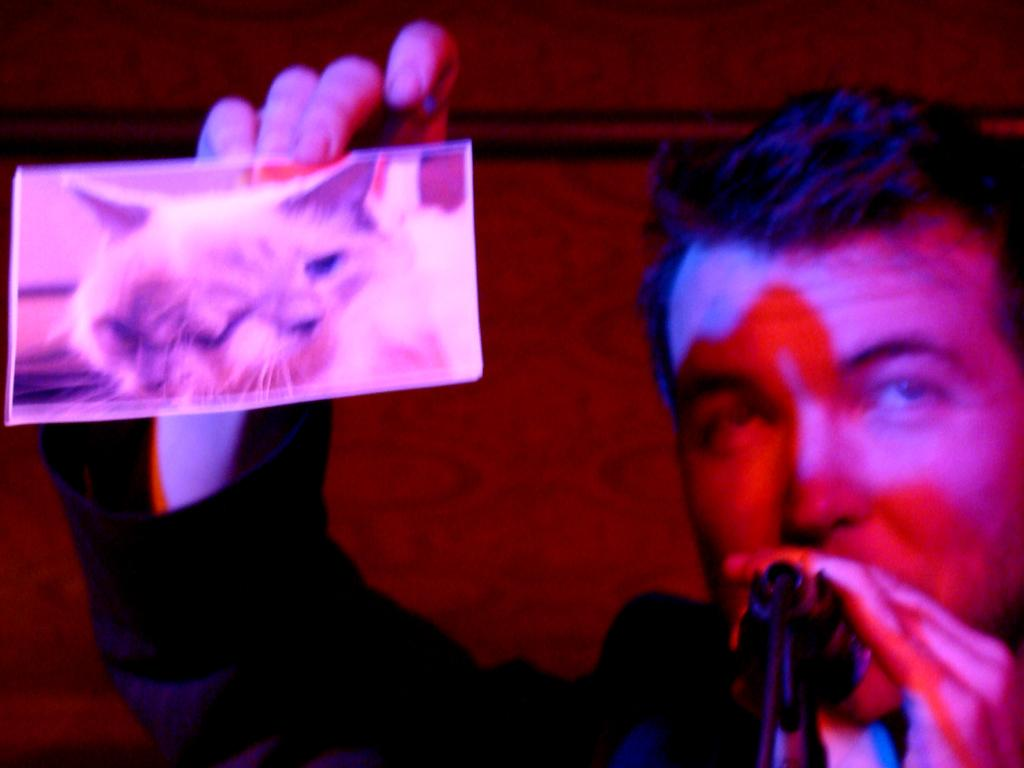What is the person in the image doing? The person is standing in the image and holding a photo of a cat. What object is in front of the person? There is a microphone in front of the person. What can be seen in the background of the image? There is a wall in the background of the image. What type of desk is visible in the image? There is no desk present in the image. How many letters are being used by the person in the image? The person is not using any letters in the image; they are holding a photo of a cat. 